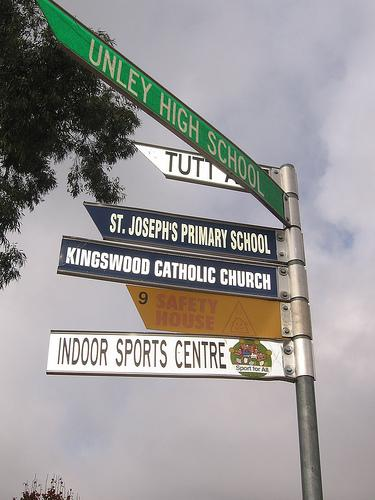Provide a succinct description of the central focus and background in the image. Street signs for various destinations, such as schools and a sport centre, are mounted on a metal pole with an overcast sky and greenery behind. Briefly explain what the main subject of the image is and what it is surrounded by. The principal subject is a metal pole with numerous street signs, including those for a high school and a sport centre, set against a backdrop of a cloudy sky and vegetation. Describe the most prominent elements of the image. Numerous street signs on a metal pole promote different destinations like schools and a sport centre, all set against a backdrop of a cloudy sky and some greenery. Briefly describe the key subject of the photo and its surroundings. A metal pole with many street signs, such as a high school sign and a sport centre sign, can be seen against an overcast sky and some plant life. Identify the primary subject in the photo and provide a concise description. The metal pole with multiple street signs, including ones for a high school and a sport centre, is the key subject amidst a cloudy sky and various plants. Explain what the main feature of the image is and describe the background. The image showcases a pole with various street signs, including ones for schools and a sport centre, set against a background of a sky full of clouds and hints of foliage. Provide a brief description of the main focus in the image. Multiple street signs attached to a metal pole including a high school sign and sport centre sign, with a cloudy sky background. Mention the primary object in the image and describe the setting. The main object is a pole with multiple street signs, like high school and sport centre signs, surrounded by a cloudy sky and green foliage. In one sentence, tell me what you see in the image. A cluster of street signs on a metal pole stand out against a backdrop featuring a cloudy sky and foliage. Summarize the central object and its surroundings in the photo. A tall pole supports various street signs about schools and a sport centre amidst an overcast sky and greenery. 